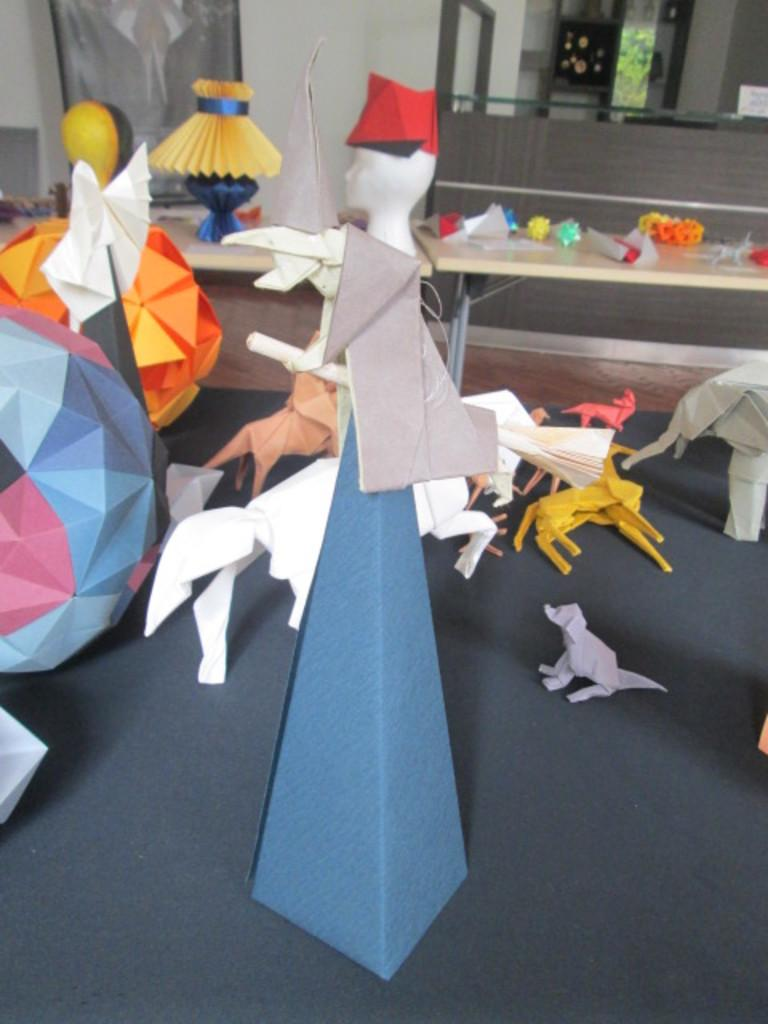What objects are on the platform in the image? There are toys on a platform in the image. What type of furniture can be seen in the image? There are tables in the image. What can be seen in the background of the image? There is a wall visible in the background of the image. How many balls are being used to measure the distance between the tables in the image? There are no balls or measurements visible in the image; it only features toys on a platform, tables, and a wall in the background. 